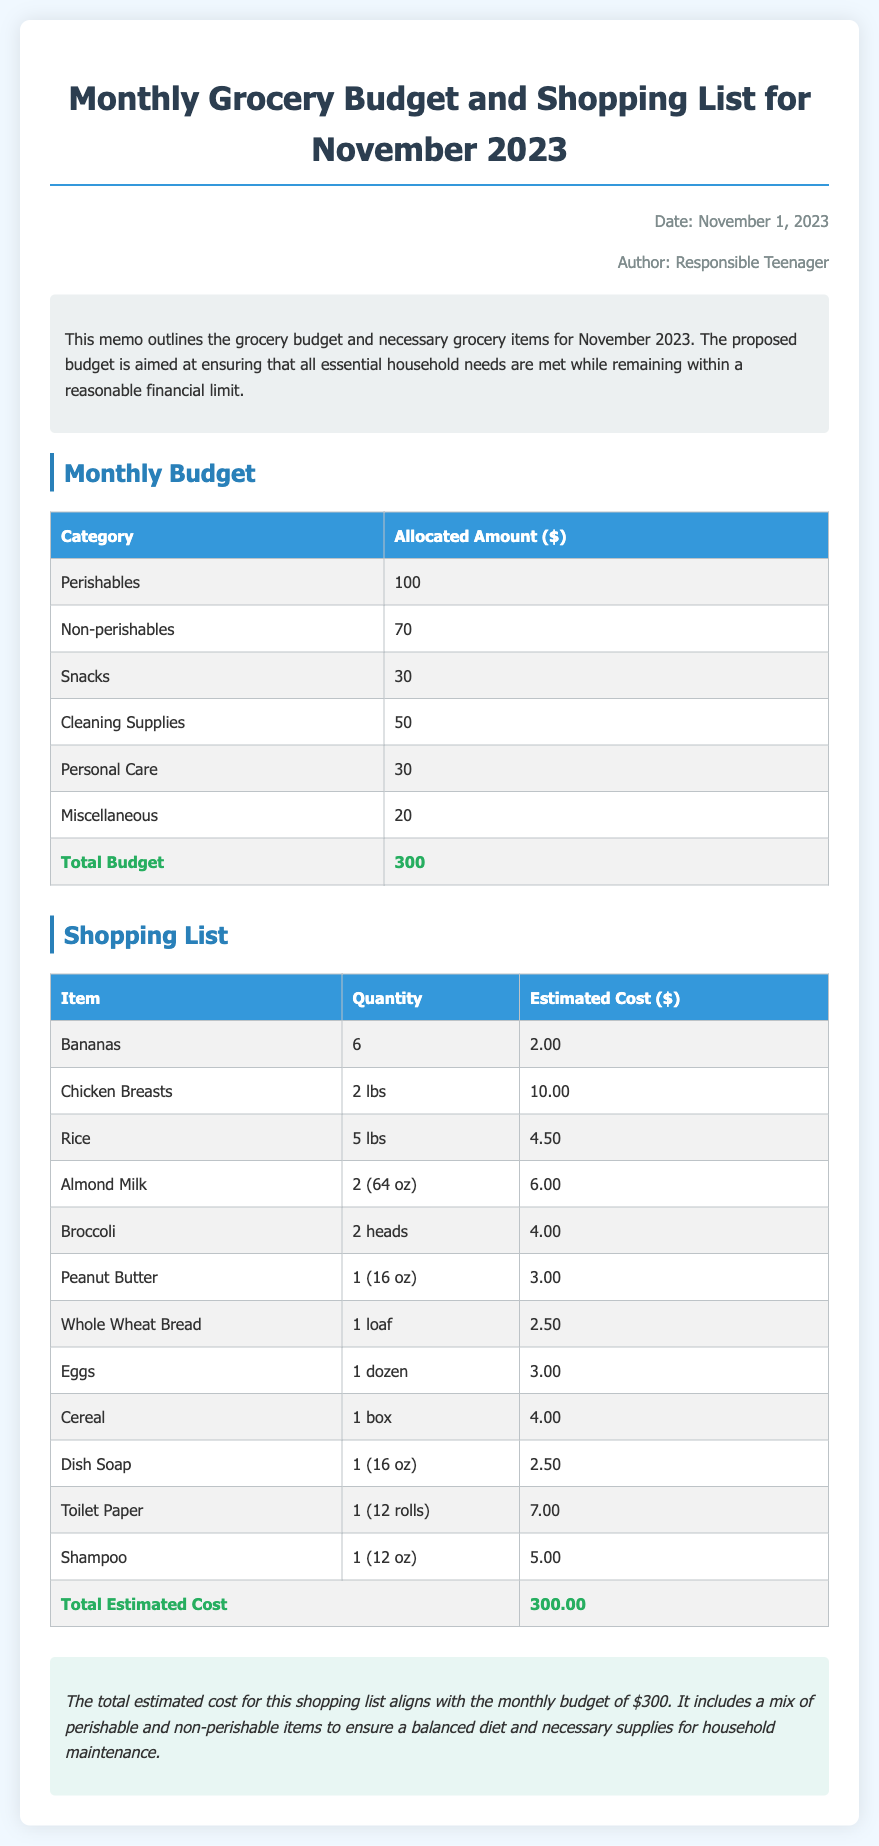What is the total budget for November 2023? The total budget is the sum of all categories listed in the document, which equals $300.
Answer: $300 How much is allocated for cleaning supplies? The allocated amount for cleaning supplies is stated in the budget section of the document.
Answer: $50 What item has the estimated cost of $10.00? The document lists chicken breasts with an estimated cost of $10.00 in the shopping list.
Answer: Chicken Breasts How many heads of broccoli are on the shopping list? The quantity of broccoli is specified in the shopping list section of the document.
Answer: 2 heads What is the total estimated cost for the shopping list? The total estimated cost is the sum of all estimated costs for the items in the shopping list.
Answer: $300.00 What month is this grocery budget and shopping list for? The document indicates that this is for November 2023 in the title.
Answer: November 2023 Which category has the lowest allocated amount in the budget? The category with the lowest allocated amount is identified in the budget section.
Answer: Miscellaneous What type of items does the budget include? The budget includes various categories like perishables, non-perishables, snacks, etc.
Answer: Perishables, Non-perishables, Snacks, Cleaning Supplies, Personal Care, Miscellaneous Who is the author of the memo? The author is mentioned at the top of the document under the metadata.
Answer: Responsible Teenager 